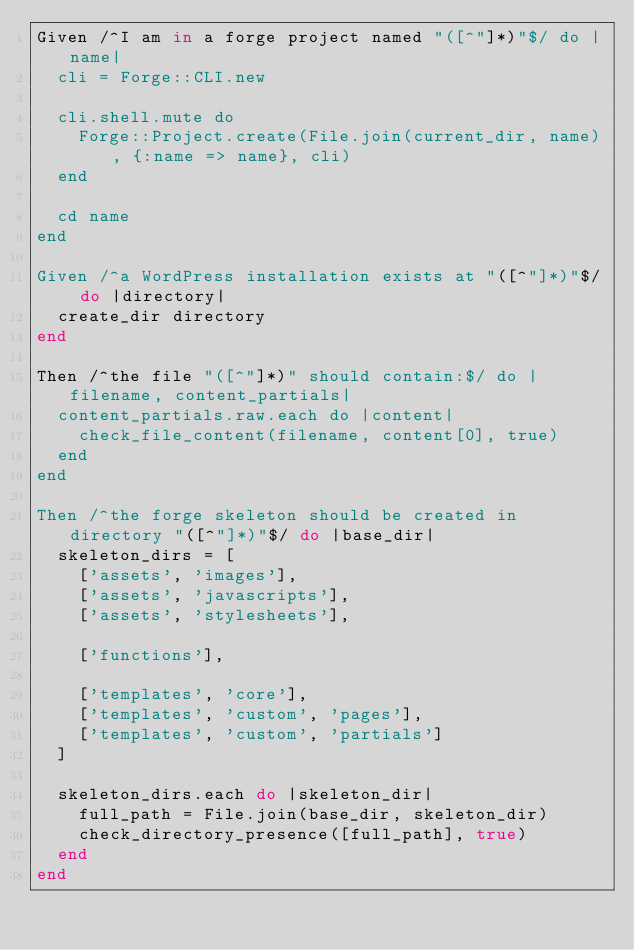Convert code to text. <code><loc_0><loc_0><loc_500><loc_500><_Ruby_>Given /^I am in a forge project named "([^"]*)"$/ do |name|
  cli = Forge::CLI.new

  cli.shell.mute do
    Forge::Project.create(File.join(current_dir, name), {:name => name}, cli)
  end

  cd name
end

Given /^a WordPress installation exists at "([^"]*)"$/ do |directory|
  create_dir directory
end

Then /^the file "([^"]*)" should contain:$/ do |filename, content_partials|
  content_partials.raw.each do |content|
    check_file_content(filename, content[0], true)
  end
end

Then /^the forge skeleton should be created in directory "([^"]*)"$/ do |base_dir|
  skeleton_dirs = [
    ['assets', 'images'],
    ['assets', 'javascripts'],
    ['assets', 'stylesheets'],

    ['functions'],

    ['templates', 'core'],
    ['templates', 'custom', 'pages'],
    ['templates', 'custom', 'partials']
  ]

  skeleton_dirs.each do |skeleton_dir|
    full_path = File.join(base_dir, skeleton_dir)
    check_directory_presence([full_path], true)
  end
end</code> 